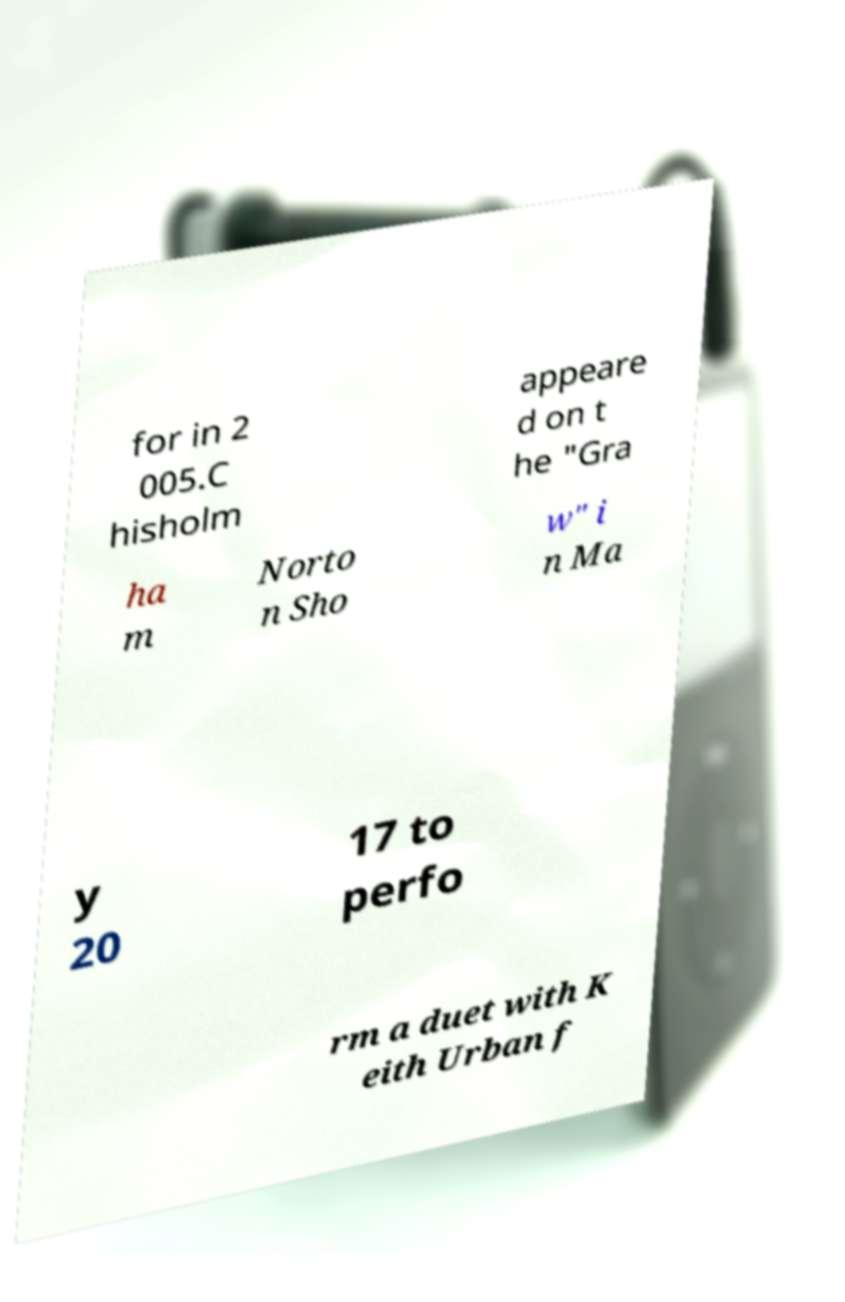What messages or text are displayed in this image? I need them in a readable, typed format. for in 2 005.C hisholm appeare d on t he "Gra ha m Norto n Sho w" i n Ma y 20 17 to perfo rm a duet with K eith Urban f 